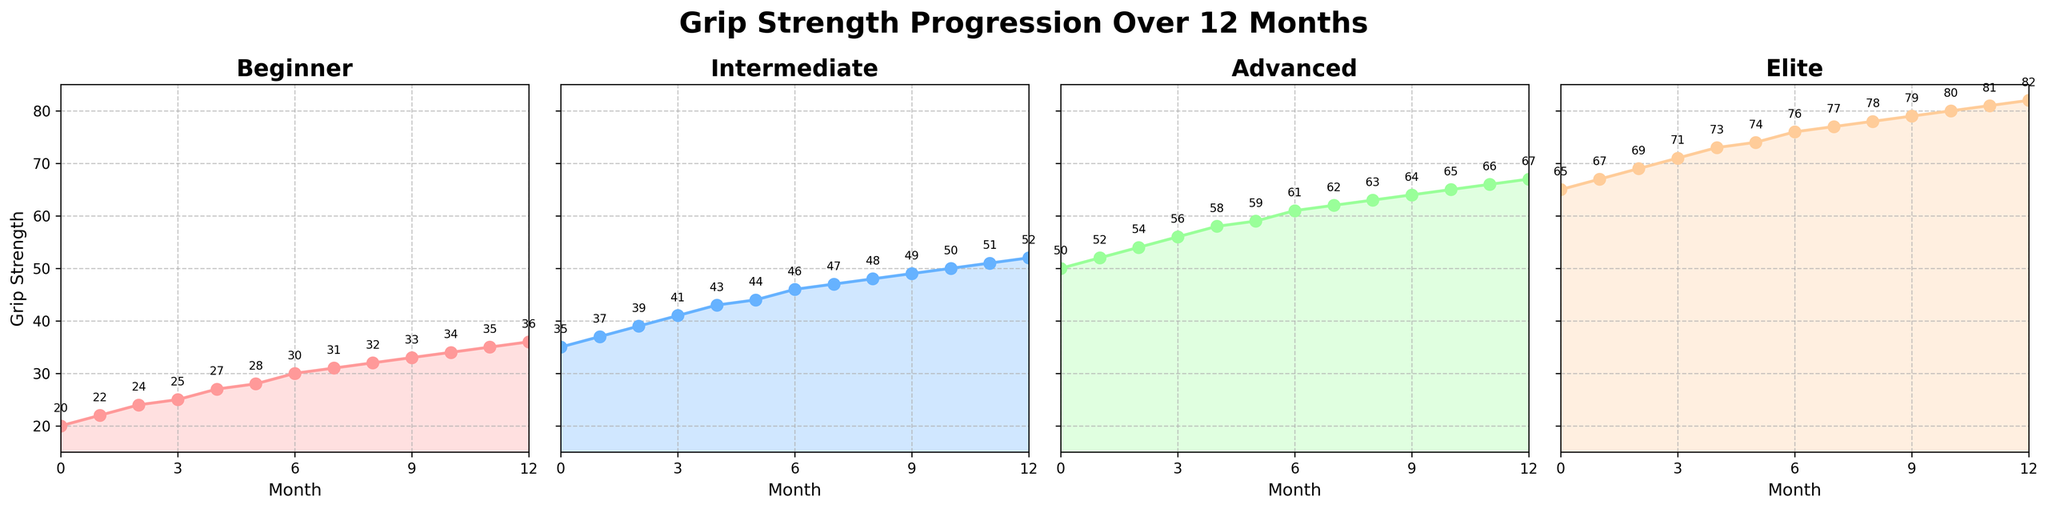What month do Beginners reach a grip strength of 36? We can track the progression line in the 'Beginner' subplot and see that Beginners reach a grip strength of 36 in month 12, as indicated by the annotation.
Answer: Month 12 Which climbing category shows the largest overall increase in grip strength over the 12 months? To find the largest overall increase, we subtract the starting grip strength from the ending grip strength for each category: Beginner (36-20=16), Intermediate (52-35=17), Advanced (67-50=17), Elite (82-65=17). The Intermediate, Advanced, and Elite categories show the largest overall increase, which is 17 units.
Answer: Intermediate, Advanced, Elite At month 6, which group has the highest grip strength? For month 6, we compare the grip strengths across all subplots: Beginner (30), Intermediate (46), Advanced (61), and Elite (76). The highest value is 76, which is in the Elite category.
Answer: Elite What is the average grip strength of the Intermediate climbers over the entire period? To compute the average grip strength of the Intermediate group, sum all the values (35+37+39+41+43+44+46+47+48+49+50+51+52 = 582) and divide by the number of data points (13 months). So, 582 / 13 = 44.77
Answer: 44.77 How much did the grip strength of Advanced climbers increase from month 3 to month 9? To find the increase, we subtract the grip strength at month 3 from the grip strength at month 9 for the Advanced category. It’s 64 (month 9) - 56 (month 3) = 8.
Answer: 8 Which months show a grip strength of 30 or more for the Beginner group? By examining the 'Beginner' subplot, we identify the months with grip strength values of 30 or more: months 6, 7, 8, 9, 10, 11, and 12.
Answer: 6, 7, 8, 9, 10, 11, 12 Do Elite climbers ever reach a grip strength of 80? In the 'Elite' subplot, observe that the grip strength reaches 80 at month 10 and remains above 80 afterward.
Answer: Yes How many months does it take Intermediate climbers to reach 50 grip strength from the start? In the 'Intermediate' subplot, we can see that Intermediate climbers reach a grip strength of 50 at month 10.
Answer: 10 months Compare the initial and final grip strengths of Beginner and Elite climbers. Which group shows a greater absolute increase? The initial and final values for Beginners are 20 and 36, respectively, for an increase of 16 units. For Elite climbers, initial is 65 and final is 82 for an increase of 17 units. Elite shows a greater absolute increase.
Answer: Elite Does the Advanced group show any months with no increase in grip strength? In the 'Advanced' subplot, every month shows an increasing trend in grip strength, with no months showing no increase.
Answer: No 